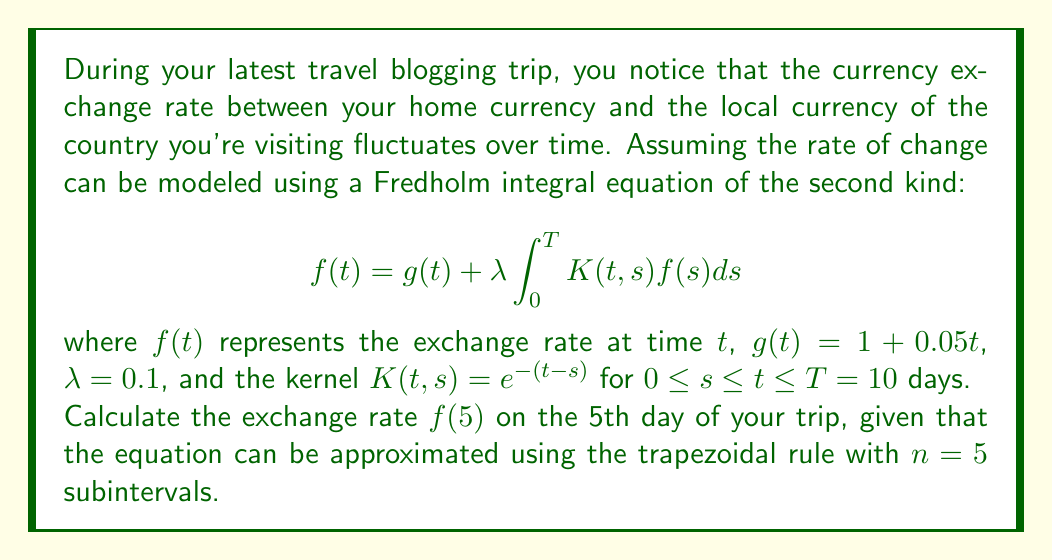Teach me how to tackle this problem. To solve this problem, we'll follow these steps:

1) First, we need to set up the trapezoidal rule approximation for the integral:

   $$\int_0^T K(t,s)f(s)ds \approx \frac{h}{2}[K(t,0)f(0) + 2K(t,h)f(h) + 2K(t,2h)f(2h) + 2K(t,3h)f(3h) + 2K(t,4h)f(4h) + K(t,T)f(T)]$$

   where $h = T/n = 10/5 = 2$

2) We need to solve this for $t = 5$. Substituting into the original equation:

   $$f(5) = g(5) + 0.1 \cdot \frac{2}{2}[K(5,0)f(0) + 2K(5,2)f(2) + 2K(5,4)f(4) + 2K(5,6)f(6) + 2K(5,8)f(8) + K(5,10)f(10)]$$

3) Calculate $g(5) = 1 + 0.05(5) = 1.25$

4) Calculate the kernel values:
   $K(5,0) = e^{-(5-0)} = e^{-5}$
   $K(5,2) = e^{-(5-2)} = e^{-3}$
   $K(5,4) = e^{-(5-4)} = e^{-1}$
   $K(5,6) = K(5,8) = K(5,10) = 0$ (since $s > t$)

5) Substituting these values:

   $$f(5) = 1.25 + 0.1[e^{-5}f(0) + 2e^{-3}f(2) + 2e^{-1}f(4)]$$

6) We don't know the values of $f(0)$, $f(2)$, and $f(4)$. However, we can set up similar equations for these:

   $$f(0) = 1 + 0.1[f(0)]$$
   $$f(2) = 1.1 + 0.1[e^{-2}f(0) + 2f(2)]$$
   $$f(4) = 1.2 + 0.1[e^{-4}f(0) + 2e^{-2}f(2) + 2f(4)]$$

7) Solving this system of equations:
   $f(0) \approx 1.1111$
   $f(2) \approx 1.2358$
   $f(4) \approx 1.3737$

8) Finally, substituting these values back into the equation for $f(5)$:

   $$f(5) = 1.25 + 0.1[e^{-5}(1.1111) + 2e^{-3}(1.2358) + 2e^{-1}(1.3737)]$$

9) Calculating this:

   $$f(5) = 1.25 + 0.1[0.0075 + 0.1836 + 1.0108] = 1.25 + 0.1202 = 1.3702$$
Answer: $f(5) \approx 1.3702$ 